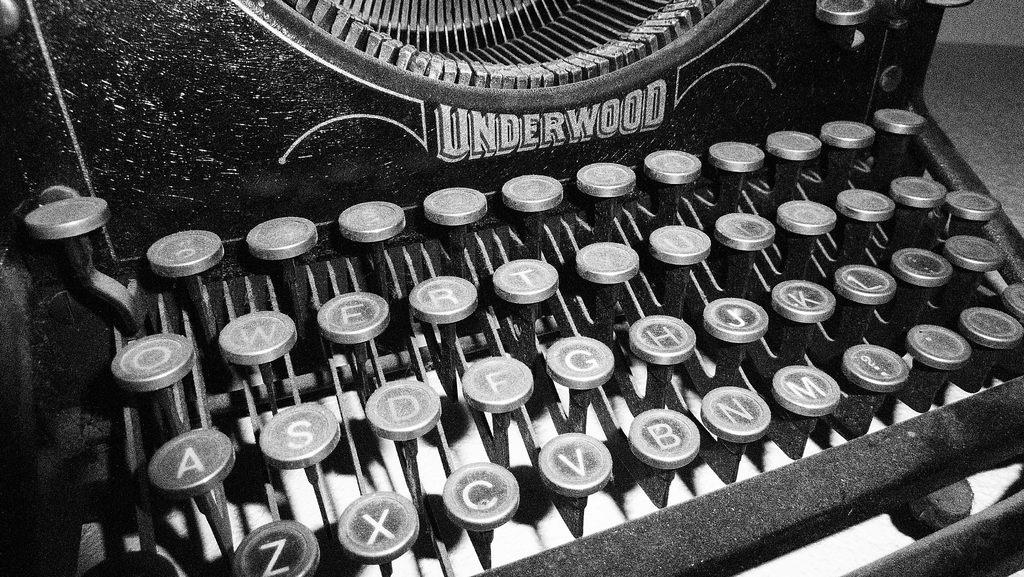What is the name of this typewriter?
Make the answer very short. Underwood. Where is the "c" key located?
Your answer should be very brief. Between x and v. 